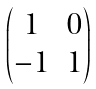Convert formula to latex. <formula><loc_0><loc_0><loc_500><loc_500>\begin{pmatrix} 1 & 0 \\ - 1 & 1 \end{pmatrix}</formula> 